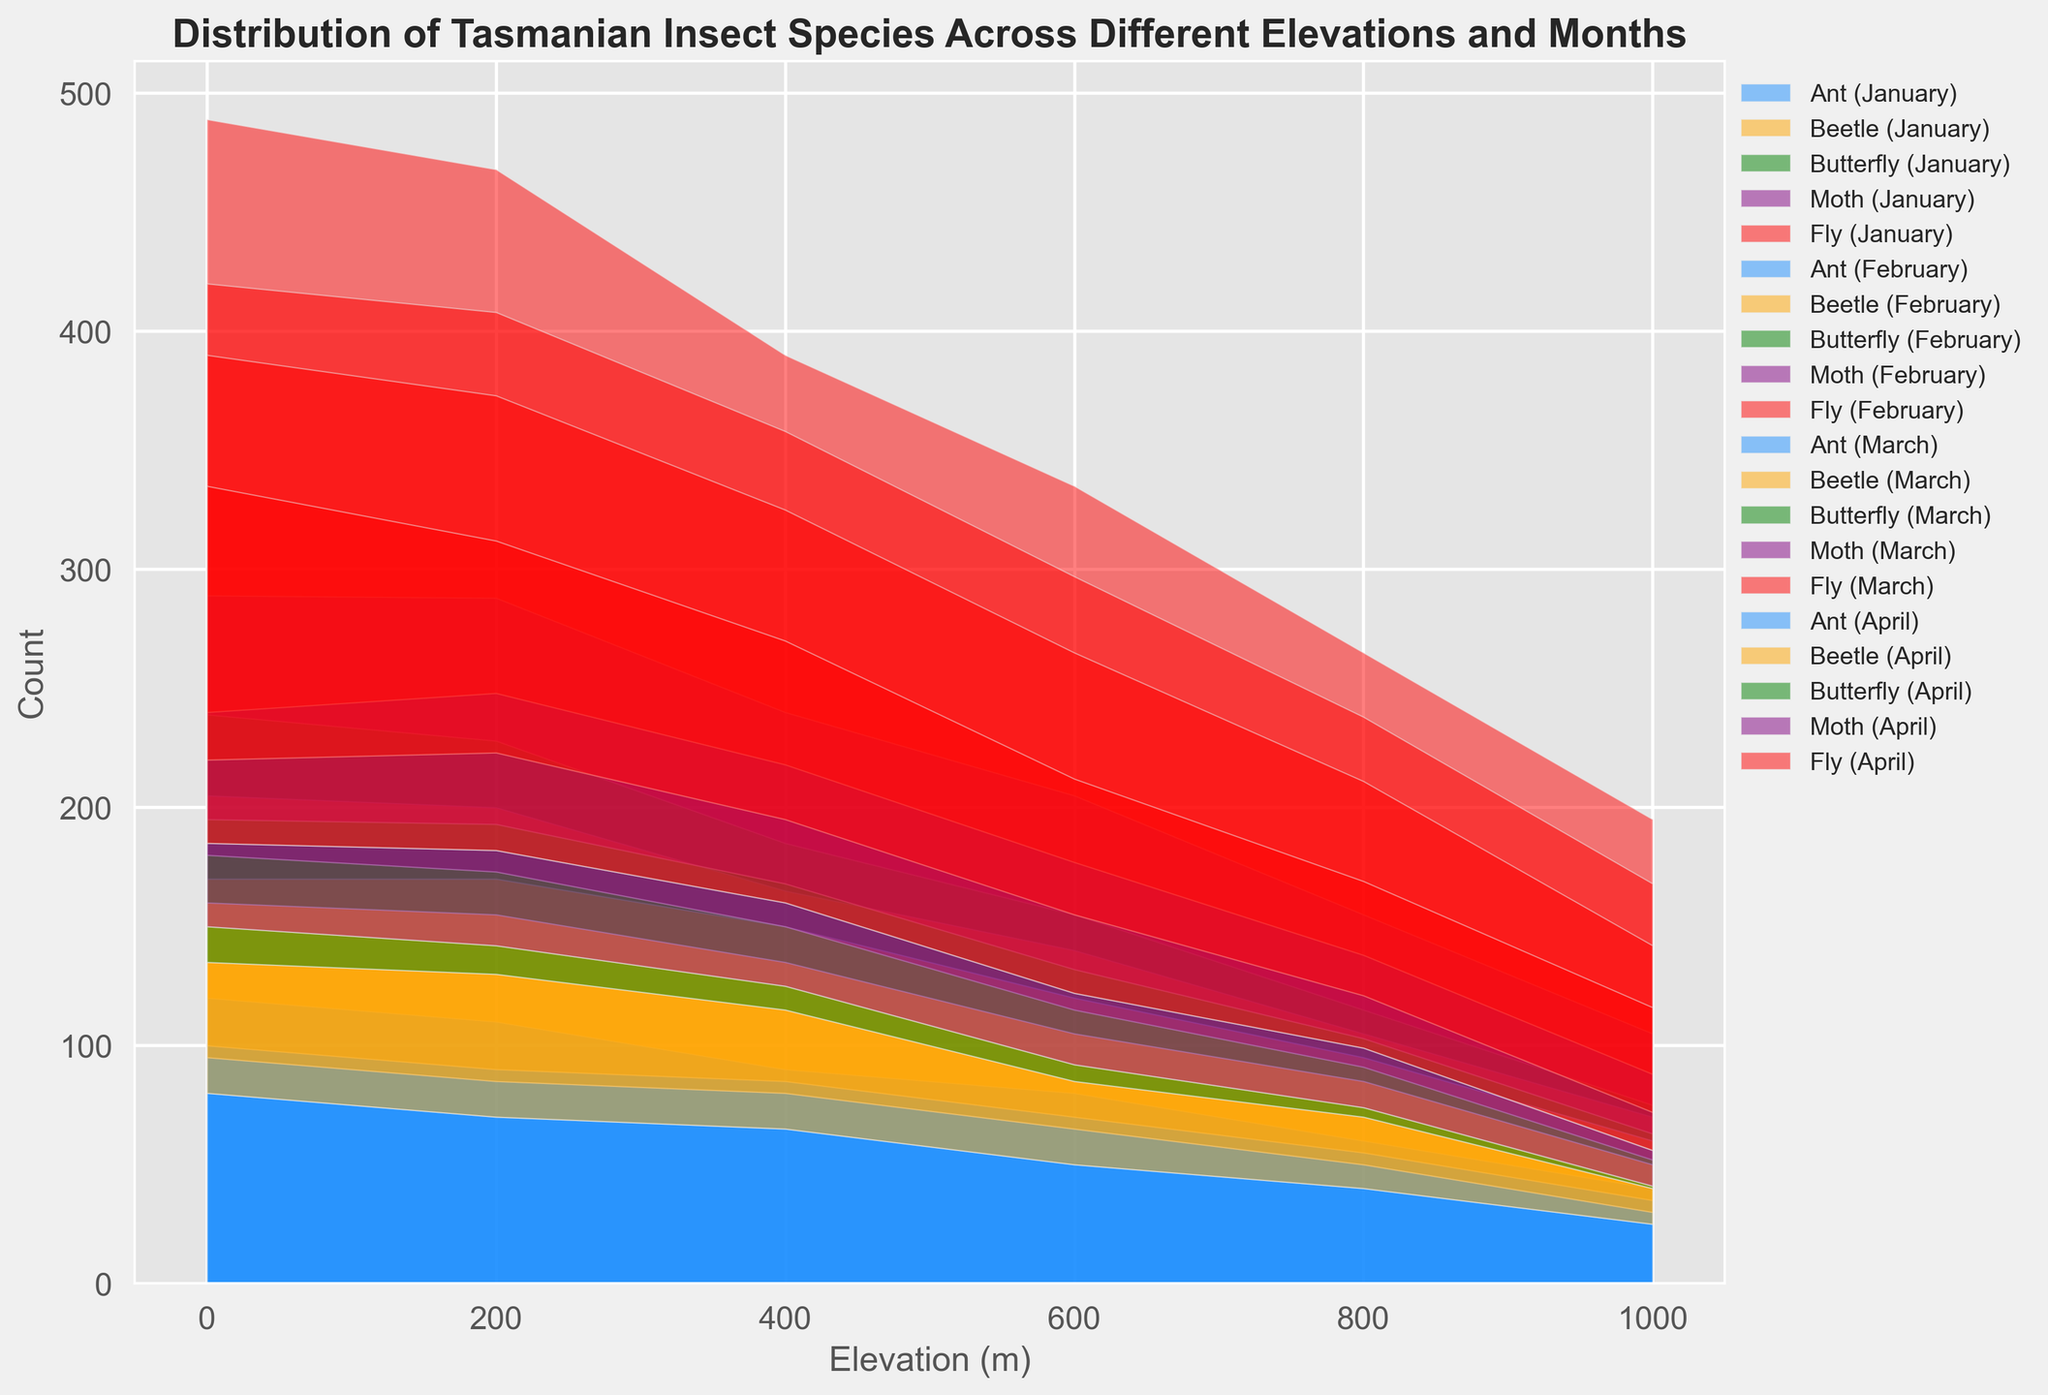How does the count of Ants change from January to April at an elevation of 400 meters? To find the change, first note the count of Ants in each month at 400 meters elevation: January (90), February (85), March (80), and April (65). The change from January to April is: 90 (January) - 65 (April) = 25.
Answer: Decreases by 25 Which species has the highest count at 200 meters elevation in March? Look at the chart for March at the 200 meters elevation level. Observe the heights of the areas representing different species. The red area (Fly) is the highest.
Answer: Fly What’s the total count of all species combined at 600 meters elevation in February? Sum the counts of all species at 600 meters elevation in February: Ant (70), Beetle (50), Butterfly (12), Moth (45), Fly (120). The total count is: 70 + 50 + 12 + 45 + 120 = 297.
Answer: 297 Compare the counts of Beetles in January and April at 0 meters elevation. Which month has a higher count, and what’s the difference? Check the counts at 0 meters elevation for Beetles in January (85) and April (55). January's count is higher. The difference is: 85 (January) - 55 (April) = 30.
Answer: January has a higher count by 30 Does the count of Moths increase or decrease with increasing elevation in January? Observe the counts of Moths at different elevations in January: 0m (50), 200m (60), 400m (55), 600m (50), 800m (40), 1000m (30). Initially, the count slightly increases, but overall, it tends to decrease as elevation increases.
Answer: Decrease What is the difference between the highest and lowest counts of Flies across all elevations in April? Identify the highest and lowest counts of Flies across elevations in April. Highest: 150 (0m), Lowest: 60 (1000m). The difference is: 150 - 60 = 90.
Answer: 90 Which month observed the highest count of Butterflies at an elevation of 200 meters? Check the Butterflies' counts at 200 meters for each month. January (28), February (23), March (18), April (12). The highest is January.
Answer: January How do the counts of Ants at 800 meters compare between January and February? Look at the counts of Ants at 800 meters elevation: January (60), February (55). January has a higher count. To find the difference: 60 - 55 = 5.
Answer: January is higher by 5 What is the trend in the count of Flies as the elevation increases from 0 to 1000 meters across all months? Examine the count of Flies at increasing elevations from 0 to 1000 meters in each month. The count of Flies decreases with increasing elevation: January (200 to 90), February (180 to 80), March (170 to 70), April (150 to 60).
Answer: Decreases 